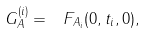<formula> <loc_0><loc_0><loc_500><loc_500>\ G _ { A } ^ { ( i ) } = \ F _ { A _ { i } } ( 0 , { t } _ { i } , 0 ) ,</formula> 